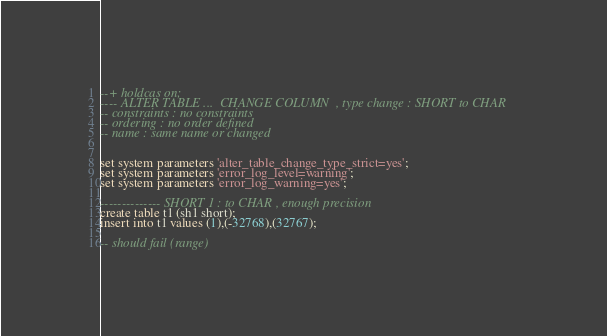Convert code to text. <code><loc_0><loc_0><loc_500><loc_500><_SQL_>--+ holdcas on;
---- ALTER TABLE ...  CHANGE COLUMN  , type change : SHORT to CHAR
-- constraints : no constraints
-- ordering : no order defined
-- name : same name or changed


set system parameters 'alter_table_change_type_strict=yes';
set system parameters 'error_log_level=warning';
set system parameters 'error_log_warning=yes';

-------------- SHORT 1 : to CHAR , enough precision
create table t1 (sh1 short);
insert into t1 values (1),(-32768),(32767);

-- should fail (range)</code> 